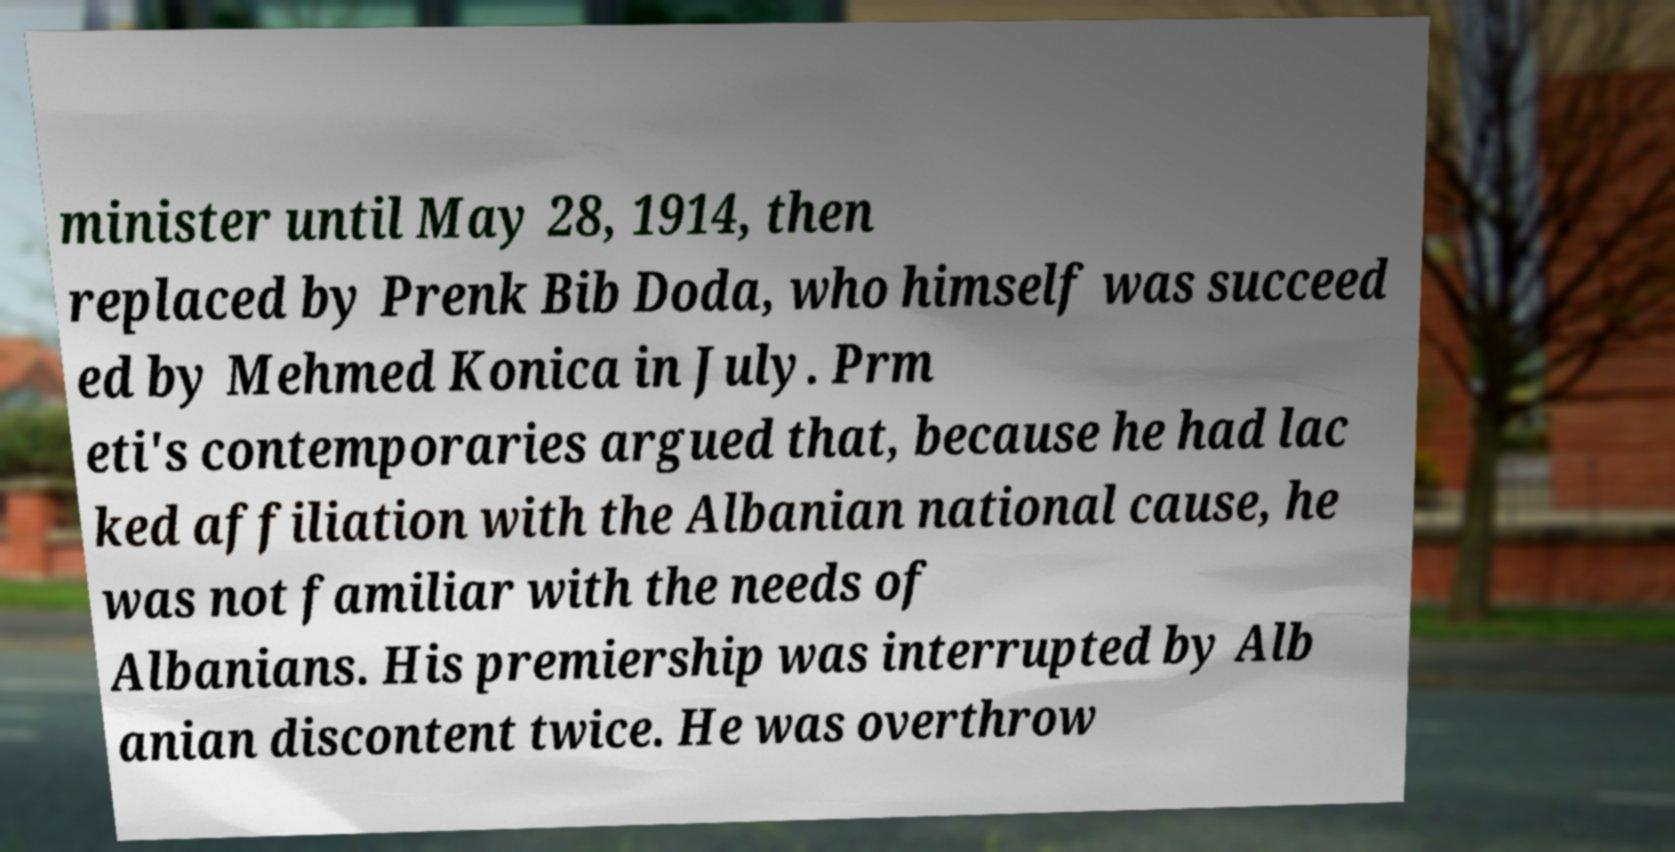Can you read and provide the text displayed in the image?This photo seems to have some interesting text. Can you extract and type it out for me? minister until May 28, 1914, then replaced by Prenk Bib Doda, who himself was succeed ed by Mehmed Konica in July. Prm eti's contemporaries argued that, because he had lac ked affiliation with the Albanian national cause, he was not familiar with the needs of Albanians. His premiership was interrupted by Alb anian discontent twice. He was overthrow 